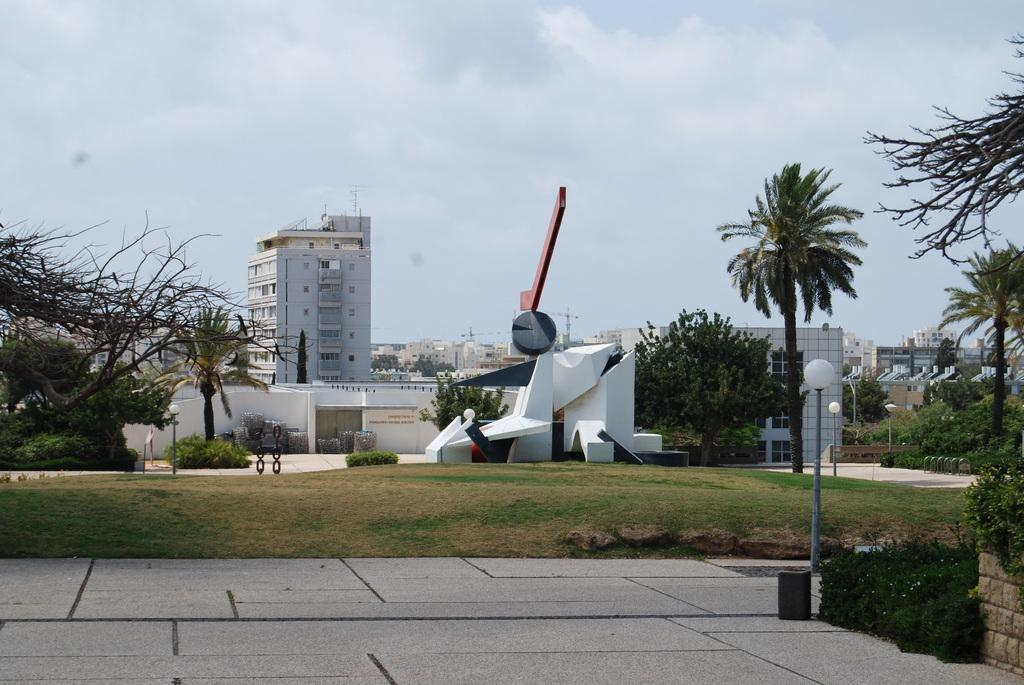What type of structures can be seen in the image? There are many buildings in the image, including a white architecture. What type of vegetation is present in the image? There are trees and grass in the image. What type of lighting is present in the image? There are lamps in the image. What is visible at the top of the image? The sky is visible at the top of the image. What type of sign can be seen in the image? There is no sign present in the image. What type of animal can be seen interacting with the lamps in the image? There are no animals present in the image; it only features buildings, trees, lamps, grass, and the sky. 